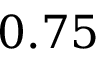<formula> <loc_0><loc_0><loc_500><loc_500>0 . 7 5</formula> 